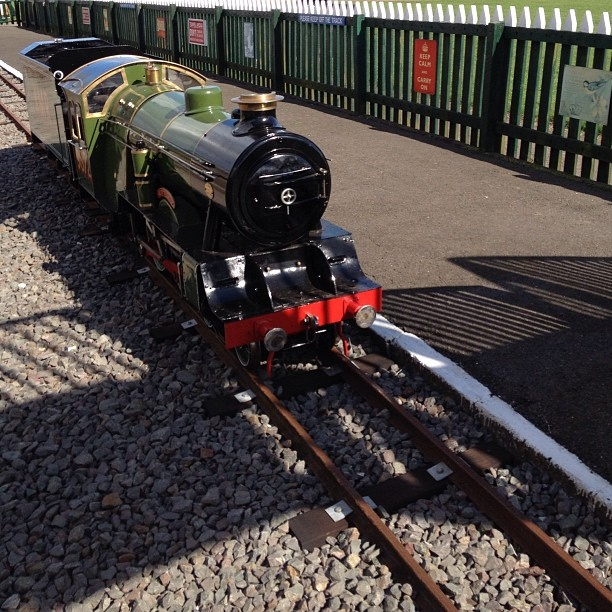Describe the objects in this image and their specific colors. I can see a train in white, black, gray, maroon, and darkgray tones in this image. 